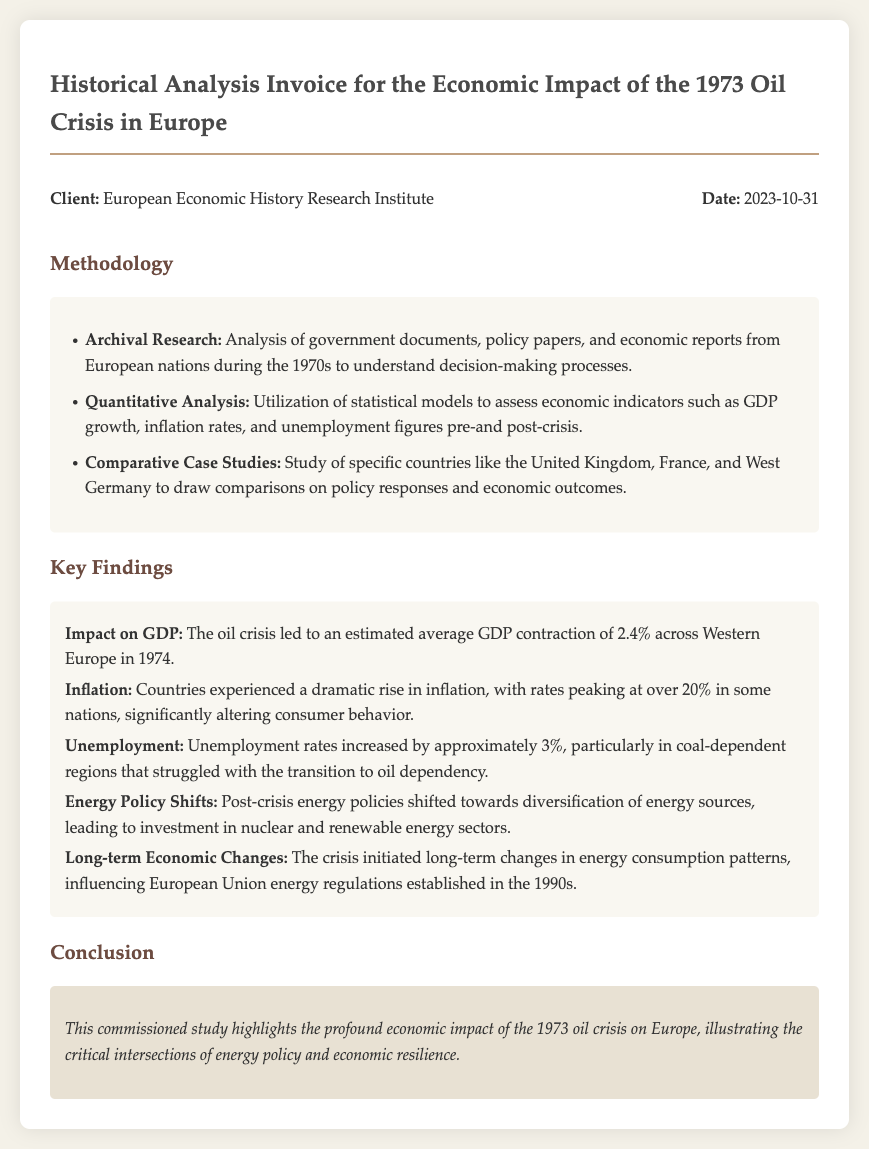What is the client name? The client's name is mentioned in the header section of the document.
Answer: European Economic History Research Institute What is the date of the invoice? The invoice date is listed in the header section along with the client's name.
Answer: 2023-10-31 What is the average GDP contraction across Western Europe in 1974? This information is presented as a key finding related to economic impacts in the document.
Answer: 2.4% What was the peak inflation rate in some nations during the crisis? The document discusses dramatic inflation rates that reached significant levels in specific countries.
Answer: Over 20% What increase in unemployment rates is indicated? The document specifies the change in unemployment rates as a result of the oil crisis.
Answer: Approximately 3% What method involves the study of specific countries for comparison? This methodology is outlined in the section detailing how the research was conducted.
Answer: Comparative Case Studies Which energy sectors saw increased investment post-crisis? Key findings reveal shifts in energy policy leading to investments in certain sectors.
Answer: Nuclear and renewable energy sectors What conclusion does the study highlight? The conclusion summarizes the overall impact of the oil crisis as identified in the study.
Answer: Economic impact of the 1973 oil crisis on Europe 